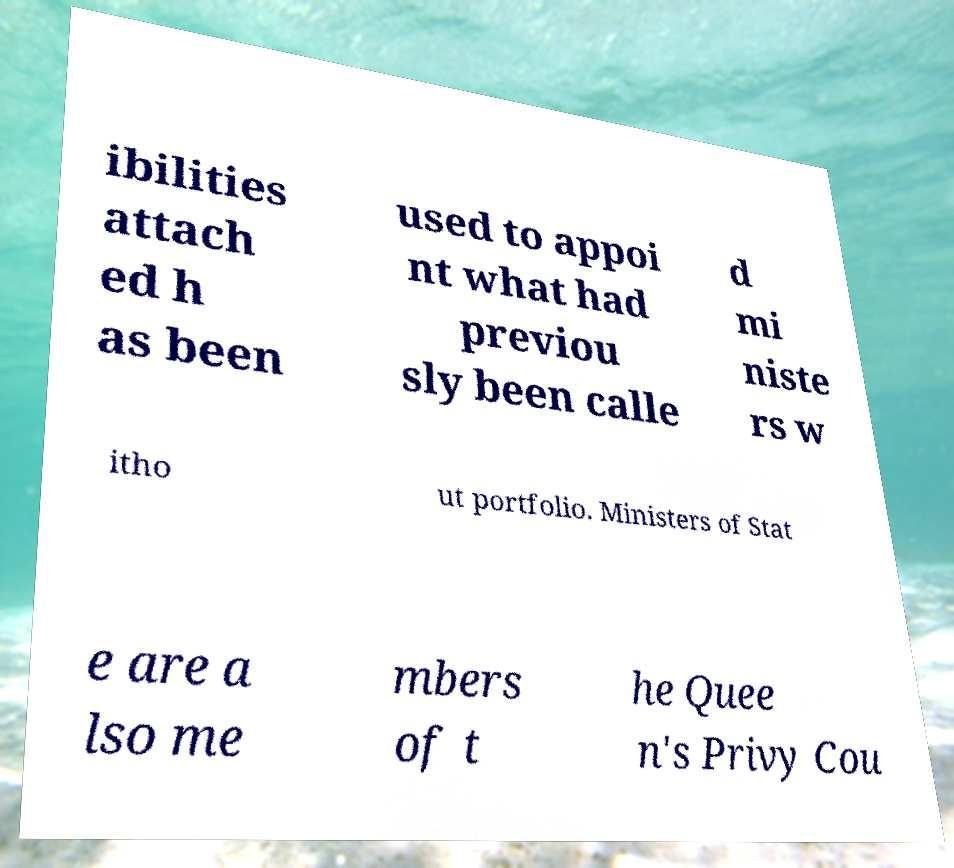Please read and relay the text visible in this image. What does it say? ibilities attach ed h as been used to appoi nt what had previou sly been calle d mi niste rs w itho ut portfolio. Ministers of Stat e are a lso me mbers of t he Quee n's Privy Cou 